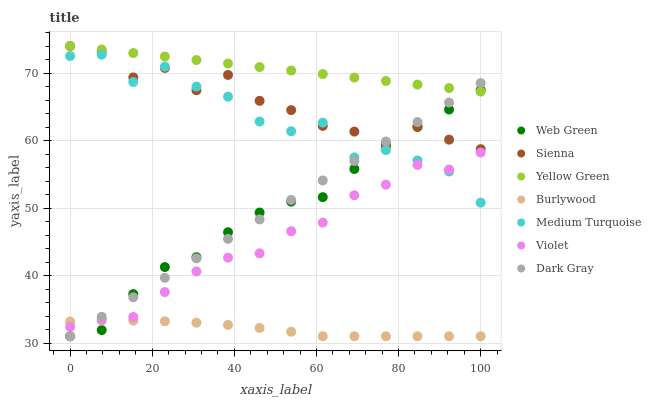Does Burlywood have the minimum area under the curve?
Answer yes or no. Yes. Does Yellow Green have the maximum area under the curve?
Answer yes or no. Yes. Does Yellow Green have the minimum area under the curve?
Answer yes or no. No. Does Burlywood have the maximum area under the curve?
Answer yes or no. No. Is Yellow Green the smoothest?
Answer yes or no. Yes. Is Medium Turquoise the roughest?
Answer yes or no. Yes. Is Burlywood the smoothest?
Answer yes or no. No. Is Burlywood the roughest?
Answer yes or no. No. Does Dark Gray have the lowest value?
Answer yes or no. Yes. Does Yellow Green have the lowest value?
Answer yes or no. No. Does Sienna have the highest value?
Answer yes or no. Yes. Does Burlywood have the highest value?
Answer yes or no. No. Is Violet less than Yellow Green?
Answer yes or no. Yes. Is Yellow Green greater than Medium Turquoise?
Answer yes or no. Yes. Does Web Green intersect Medium Turquoise?
Answer yes or no. Yes. Is Web Green less than Medium Turquoise?
Answer yes or no. No. Is Web Green greater than Medium Turquoise?
Answer yes or no. No. Does Violet intersect Yellow Green?
Answer yes or no. No. 